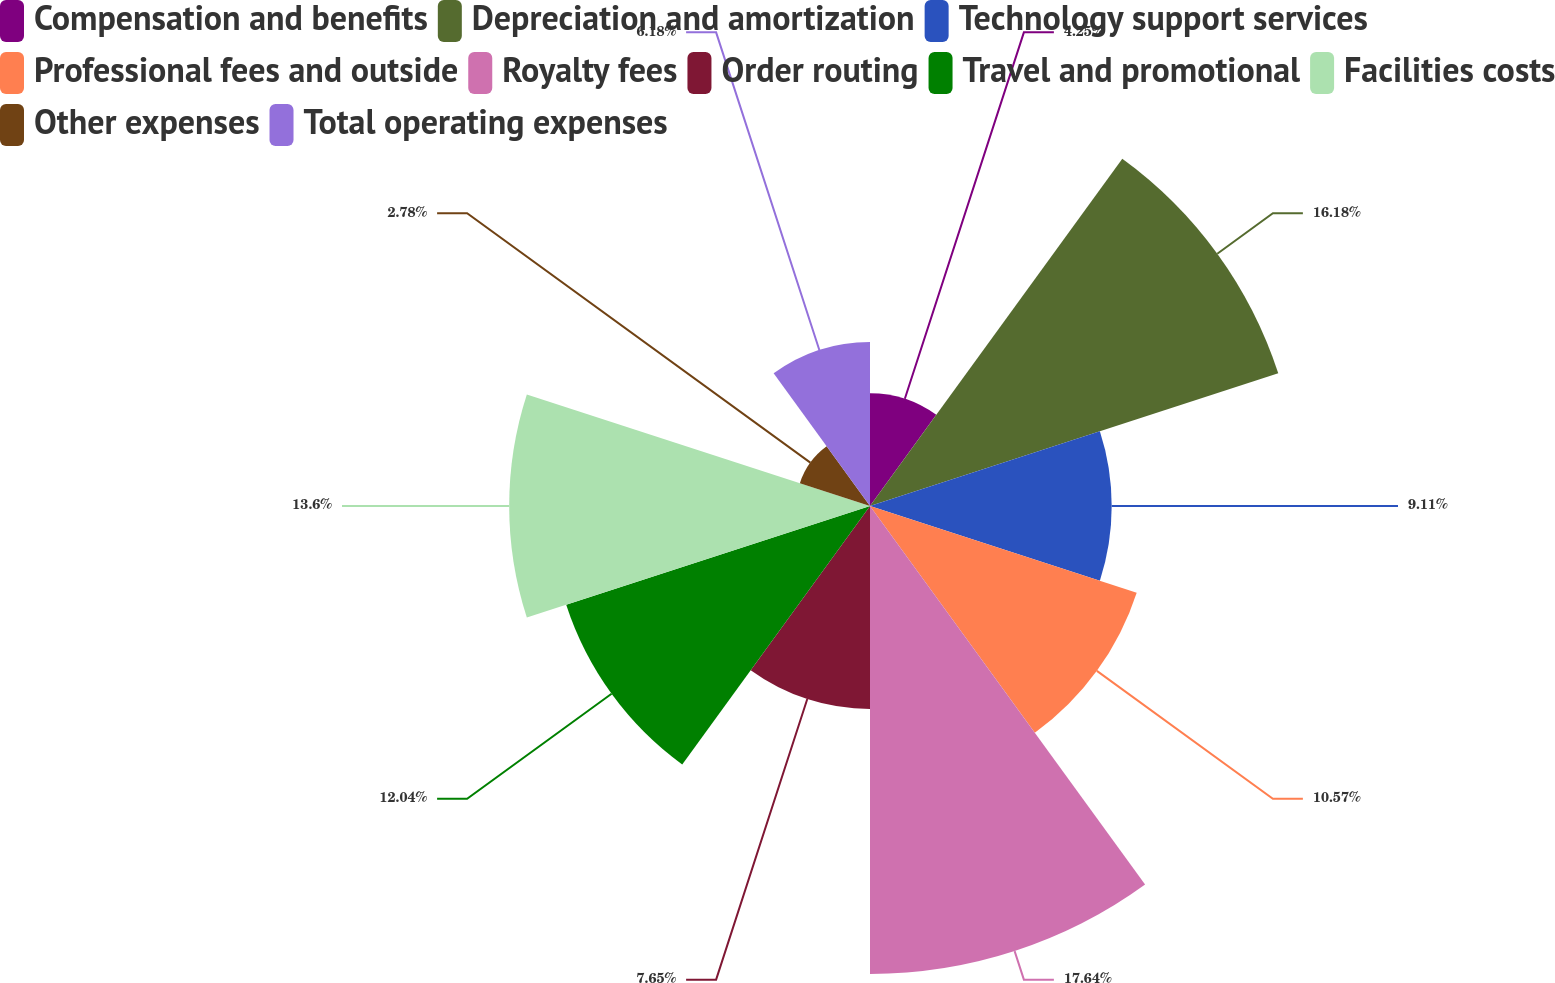<chart> <loc_0><loc_0><loc_500><loc_500><pie_chart><fcel>Compensation and benefits<fcel>Depreciation and amortization<fcel>Technology support services<fcel>Professional fees and outside<fcel>Royalty fees<fcel>Order routing<fcel>Travel and promotional<fcel>Facilities costs<fcel>Other expenses<fcel>Total operating expenses<nl><fcel>4.25%<fcel>16.18%<fcel>9.11%<fcel>10.57%<fcel>17.64%<fcel>7.65%<fcel>12.04%<fcel>13.6%<fcel>2.78%<fcel>6.18%<nl></chart> 